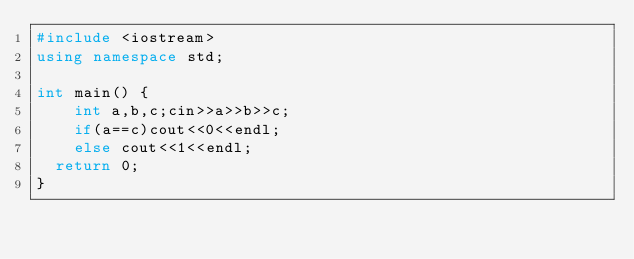Convert code to text. <code><loc_0><loc_0><loc_500><loc_500><_C++_>#include <iostream>
using namespace std;

int main() {
    int a,b,c;cin>>a>>b>>c;
    if(a==c)cout<<0<<endl;
    else cout<<1<<endl;
	return 0;
}
</code> 